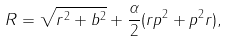<formula> <loc_0><loc_0><loc_500><loc_500>R = \sqrt { r ^ { 2 } + b ^ { 2 } } + \frac { \alpha } { 2 } ( r p ^ { 2 } + p ^ { 2 } r ) ,</formula> 